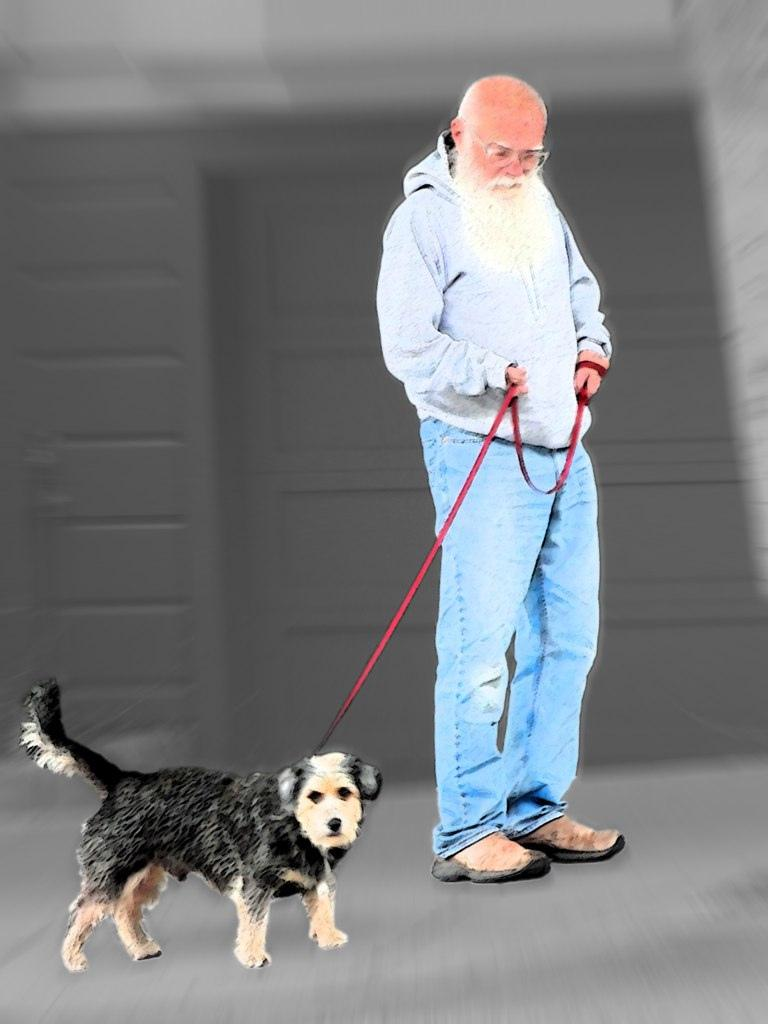What is the man in the image wearing? The man is wearing a grey jacket. What is the man holding in the image? The man is holding a rope. What type of animal is in the image with the man? There is a dog in the image. What color is the dog? The dog is black. How is the dog connected to the man? The dog is connected to the man by the rope. What can be seen in the background of the image? There is a grey wall in the background of the image. What type of protest is the man participating in with the bag in the image? There is no protest or bag present in the image. How many hands can be seen holding the rope in the image? There is only one hand visible in the image, as it is the man holding the rope. 